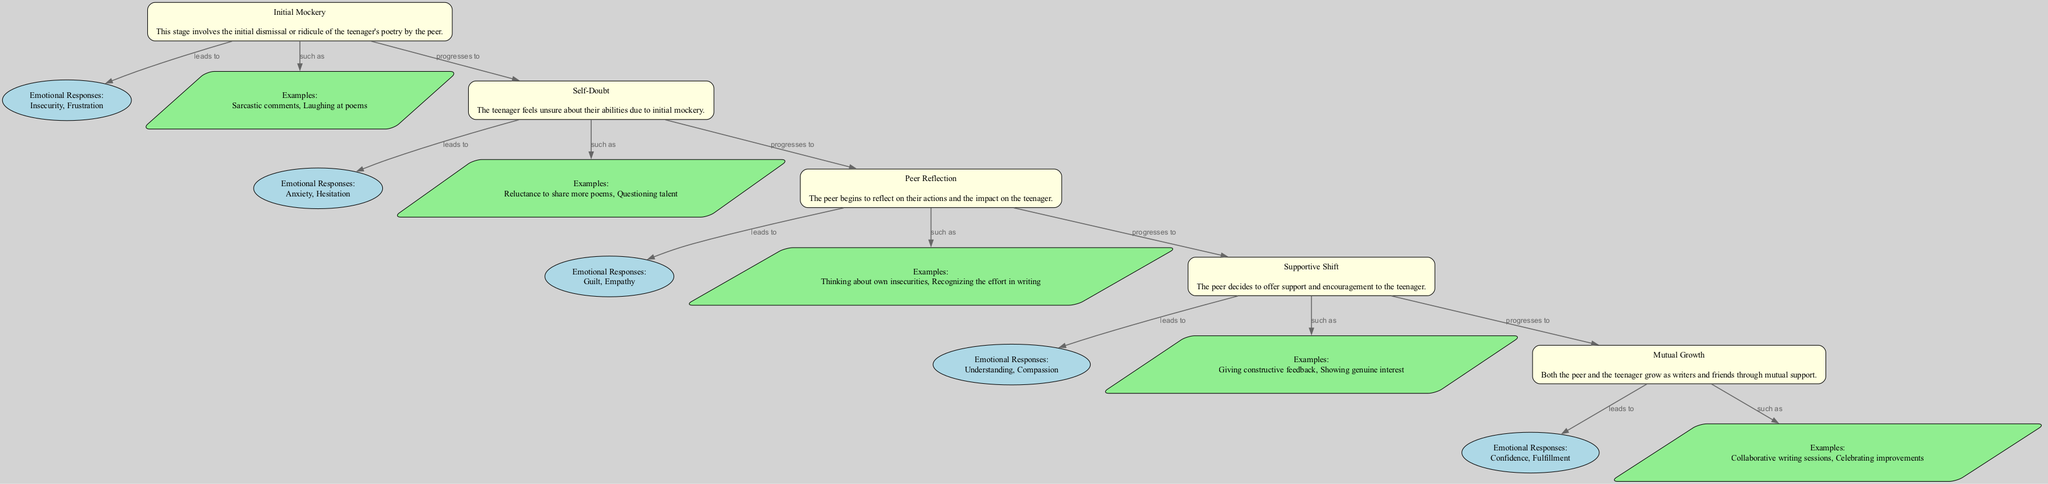What is the first stage in the emotional map? The first stage, as indicated at the top of the diagram, is "Initial Mockery." This is derived from the sequential order of the stages depicted in the concept map.
Answer: Initial Mockery How many emotional responses are listed for "Supportive Shift"? In the diagram, the emotional responses section for "Supportive Shift" mentions two responses: "Understanding" and "Compassion." By counting these, we find that there are two total responses listed.
Answer: 2 What stage directly follows "Self-Doubt"? The stage that directly follows "Self-Doubt" is identified by the connecting edge in the diagram that proceeds to the next stage, which is "Peer Reflection." The sequential nature of the stages clearly indicates this order.
Answer: Peer Reflection Which emotional response is associated with "Mutual Growth"? The emotional responses associated with "Mutual Growth" include "Confidence" and "Fulfillment," which are displayed as part of that stage’s details in the diagram. Specifically, the query is about what is mentioned under the emotional responses section for that stage.
Answer: Confidence, Fulfillment What is an example given for the "Self-Doubt" stage? An example provided under the "Self-Doubt" stage indicates the teenager's experience as "Reluctance to share more poems." This is found in the examples section for that particular stage in the diagram.
Answer: Reluctance to share more poems Which two stages are directly connected through a "progresses to" edge? The specific stages connected through a "progresses to" edge can be traced from the diagram. For instance, "Initial Mockery" progresses to "Self-Doubt," illustrating the emotional transition between these stages.
Answer: Initial Mockery, Self-Doubt How many stages are represented in the diagram? The total number of stages is determined by counting each distinct stage node present in the diagram. The diagram includes a total of five stages, including "Initial Mockery," "Self-Doubt," "Peer Reflection," "Supportive Shift," and "Mutual Growth."
Answer: 5 What emotion accompanies the "Peer Reflection" stage? The emotional responses related to the "Peer Reflection" stage are "Guilt" and "Empathy," as displayed in the emotional responses section of that stage in the diagram, thereby revealing the feelings involved during this stage.
Answer: Guilt, Empathy 